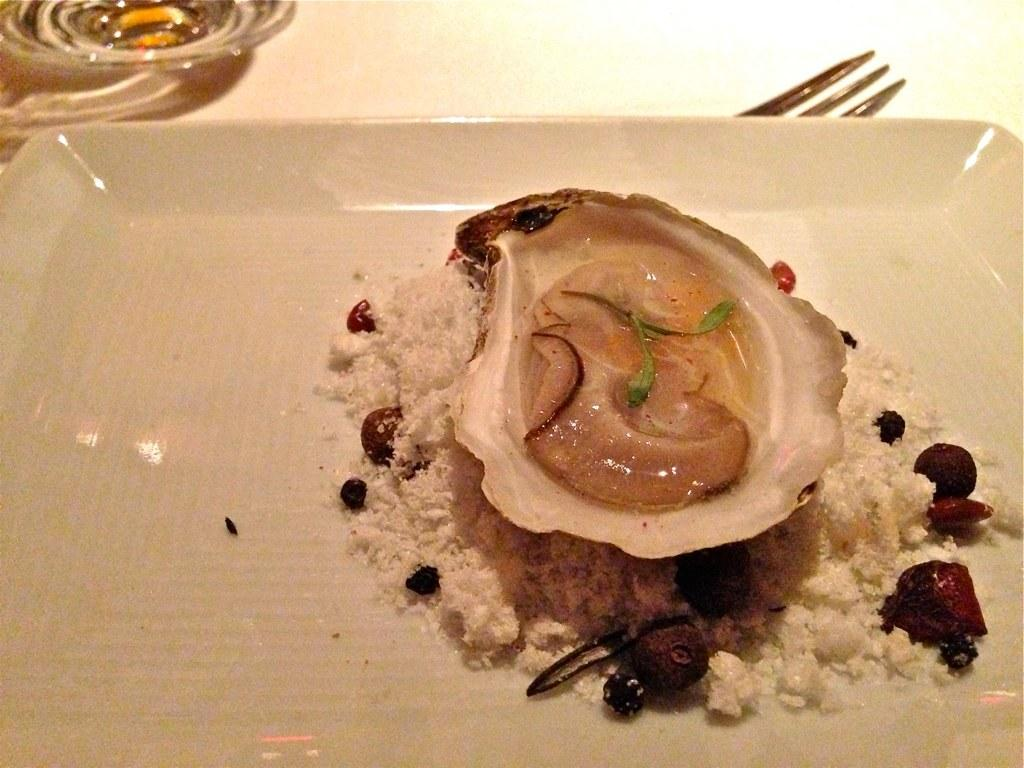What is the main subject of the image? The main subject of the image is an oyster. How is the oyster being stored or displayed? The oyster is kept in a tray. What utensil is visible in the image? There is a fork visible in the image. What type of skin condition can be seen on the baby in the image? There is no baby present in the image, only an oyster in a tray and a fork. How long does it take for the hour to pass in the image? The concept of time passing is not applicable to a still image. 